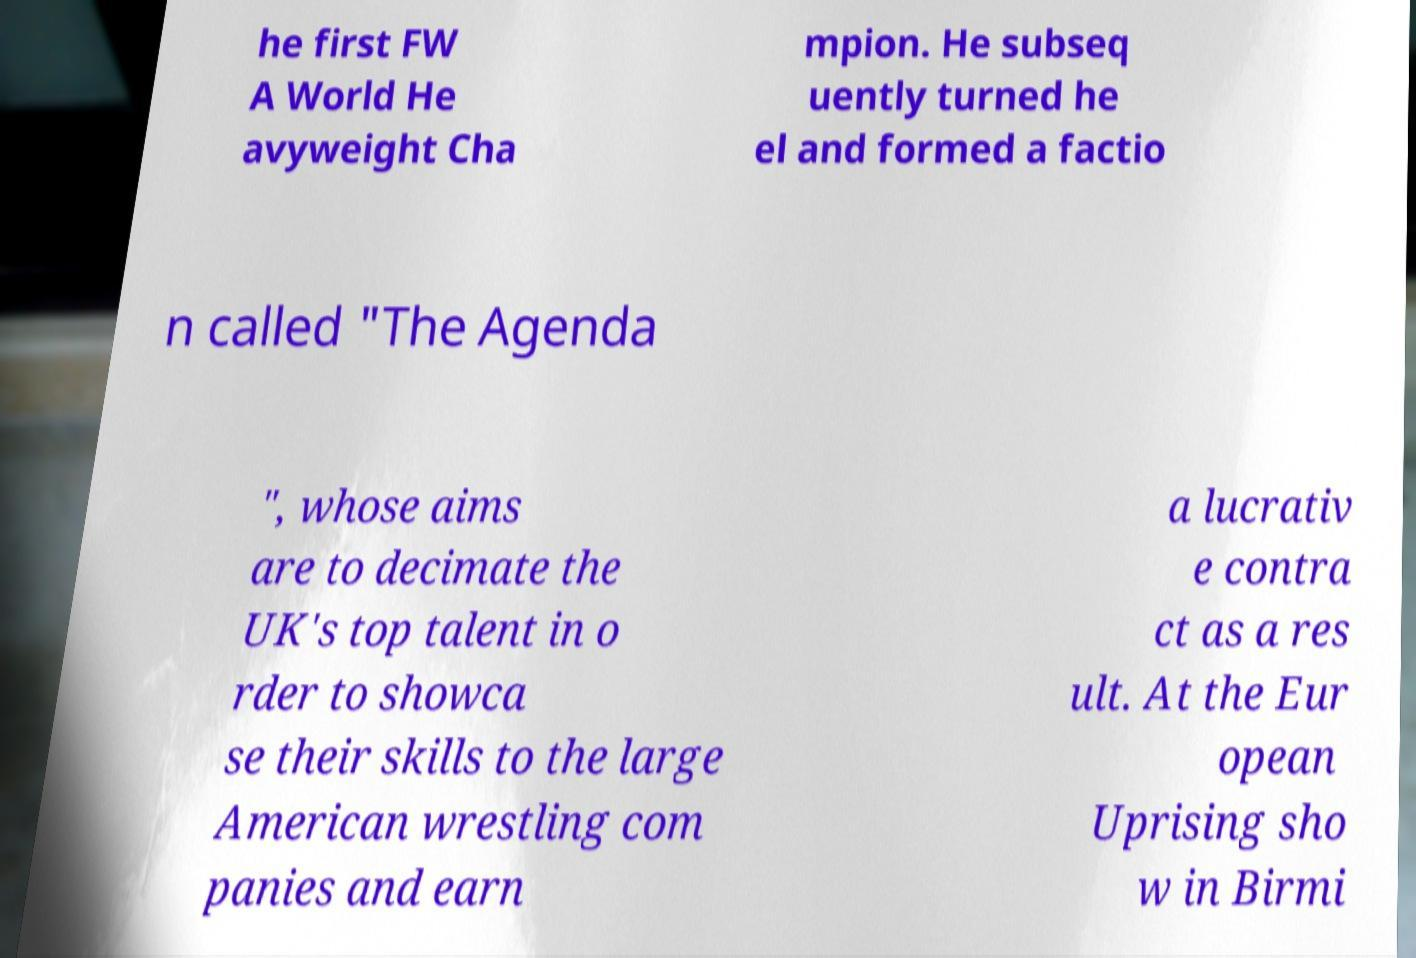Can you read and provide the text displayed in the image?This photo seems to have some interesting text. Can you extract and type it out for me? he first FW A World He avyweight Cha mpion. He subseq uently turned he el and formed a factio n called "The Agenda ", whose aims are to decimate the UK's top talent in o rder to showca se their skills to the large American wrestling com panies and earn a lucrativ e contra ct as a res ult. At the Eur opean Uprising sho w in Birmi 